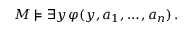Convert formula to latex. <formula><loc_0><loc_0><loc_500><loc_500>M \models \exists y \, \varphi ( y , a _ { 1 } , \dots , a _ { n } ) \, .</formula> 